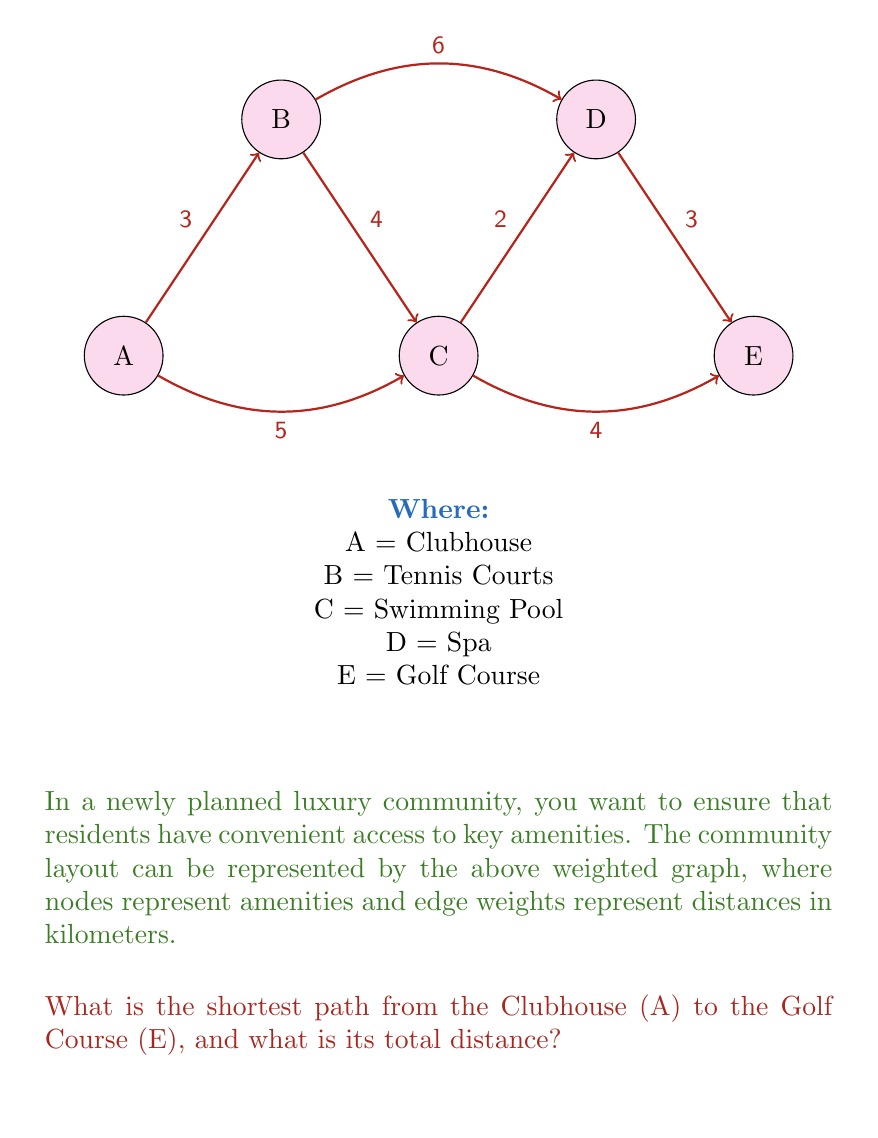What is the answer to this math problem? To solve this problem, we'll use Dijkstra's algorithm to find the shortest path from A to E.

Step 1: Initialize distances
- Set distance to A as 0
- Set distances to all other nodes as infinity

Step 2: Visit node A
- Update distances:
  B: min(∞, 0 + 3) = 3
  C: min(∞, 0 + 5) = 5

Step 3: Visit node B (closest unvisited node)
- Update distances:
  C: min(5, 3 + 4) = 5 (no change)
  D: min(∞, 3 + 6) = 9

Step 4: Visit node C
- Update distances:
  D: min(9, 5 + 2) = 7
  E: min(∞, 5 + 4) = 9

Step 5: Visit node D
- Update distances:
  E: min(9, 7 + 3) = 9 (no change)

Step 6: Visit node E
- All nodes visited, algorithm terminates

The shortest path is A → C → E with a total distance of 9 km.

We can verify this:
A → C = 5 km
C → E = 4 km
Total = 5 + 4 = 9 km

This is indeed shorter than other possible paths:
A → B → C → E = 3 + 4 + 4 = 11 km
A → B → D → E = 3 + 6 + 3 = 12 km
A → C → D → E = 5 + 2 + 3 = 10 km
Answer: A → C → E, 9 km 